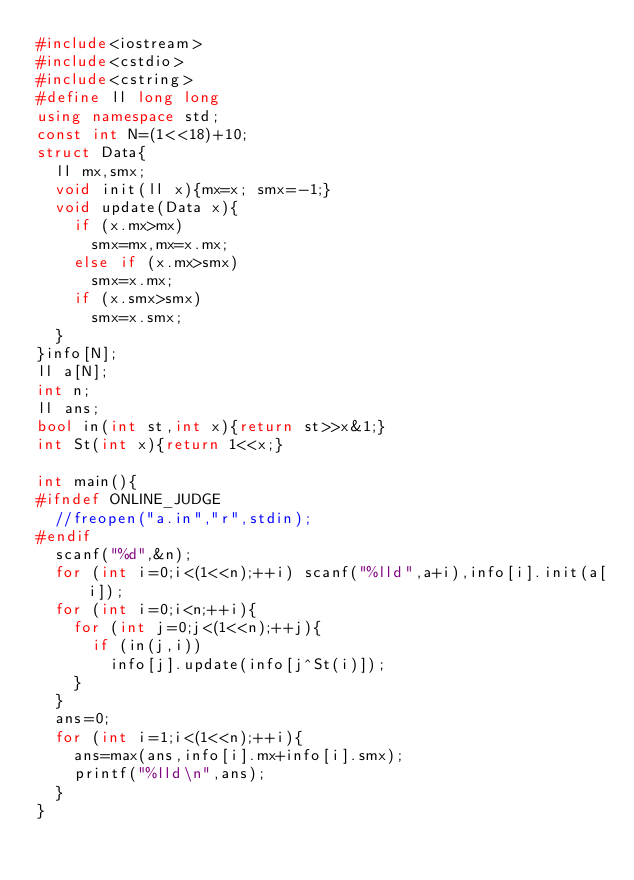Convert code to text. <code><loc_0><loc_0><loc_500><loc_500><_C++_>#include<iostream>
#include<cstdio>
#include<cstring>
#define ll long long
using namespace std;
const int N=(1<<18)+10;
struct Data{
	ll mx,smx;
	void init(ll x){mx=x; smx=-1;}
	void update(Data x){
		if (x.mx>mx)
			smx=mx,mx=x.mx;
		else if (x.mx>smx)
			smx=x.mx;
		if (x.smx>smx)
			smx=x.smx;
	}
}info[N];
ll a[N];
int n;
ll ans;
bool in(int st,int x){return st>>x&1;}
int St(int x){return 1<<x;}

int main(){
#ifndef ONLINE_JUDGE
	//freopen("a.in","r",stdin);
#endif
	scanf("%d",&n);
	for (int i=0;i<(1<<n);++i) scanf("%lld",a+i),info[i].init(a[i]);
	for (int i=0;i<n;++i){
		for (int j=0;j<(1<<n);++j){
			if (in(j,i))
				info[j].update(info[j^St(i)]);
		}
	}
	ans=0;
	for (int i=1;i<(1<<n);++i){
		ans=max(ans,info[i].mx+info[i].smx);
		printf("%lld\n",ans);
	}
}
</code> 